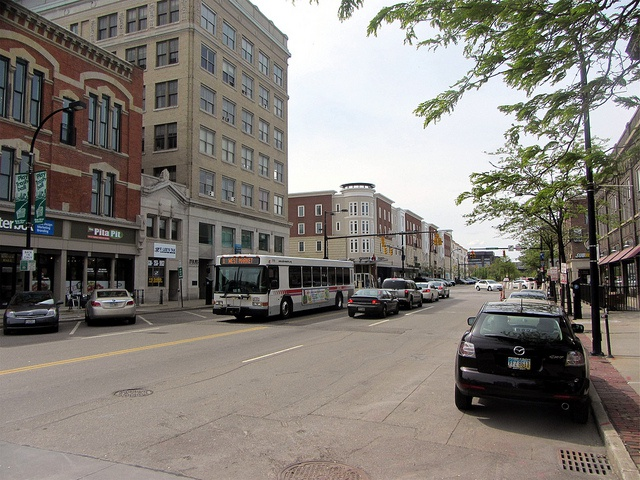Describe the objects in this image and their specific colors. I can see car in black, gray, and darkgray tones, bus in black and gray tones, car in black, gray, and darkgray tones, car in black, gray, and darkgray tones, and car in black, darkgray, gray, and maroon tones in this image. 